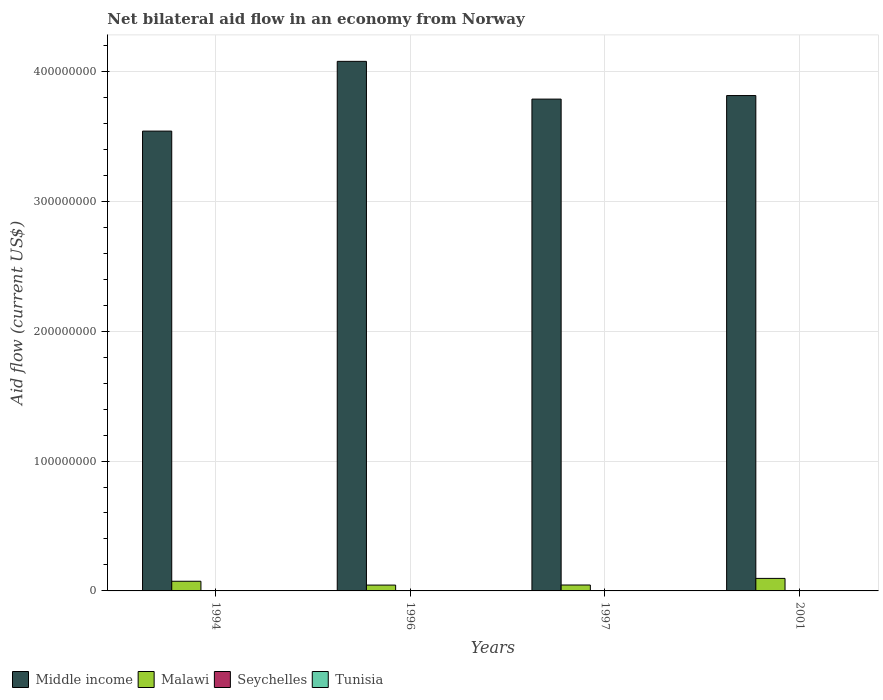How many groups of bars are there?
Provide a short and direct response. 4. How many bars are there on the 1st tick from the right?
Your answer should be compact. 4. What is the label of the 1st group of bars from the left?
Provide a short and direct response. 1994. In how many cases, is the number of bars for a given year not equal to the number of legend labels?
Offer a very short reply. 0. What is the net bilateral aid flow in Seychelles in 1997?
Your response must be concise. 2.00e+04. Across all years, what is the maximum net bilateral aid flow in Malawi?
Offer a very short reply. 9.64e+06. Across all years, what is the minimum net bilateral aid flow in Malawi?
Make the answer very short. 4.49e+06. In which year was the net bilateral aid flow in Malawi maximum?
Ensure brevity in your answer.  2001. What is the total net bilateral aid flow in Malawi in the graph?
Provide a succinct answer. 2.61e+07. What is the difference between the net bilateral aid flow in Seychelles in 1996 and the net bilateral aid flow in Malawi in 1994?
Ensure brevity in your answer.  -7.29e+06. What is the average net bilateral aid flow in Middle income per year?
Offer a very short reply. 3.80e+08. In the year 2001, what is the difference between the net bilateral aid flow in Middle income and net bilateral aid flow in Tunisia?
Make the answer very short. 3.81e+08. In how many years, is the net bilateral aid flow in Tunisia greater than 100000000 US$?
Your answer should be very brief. 0. What is the ratio of the net bilateral aid flow in Tunisia in 1996 to that in 2001?
Offer a terse response. 1. What is the difference between the highest and the second highest net bilateral aid flow in Middle income?
Your response must be concise. 2.63e+07. What is the difference between the highest and the lowest net bilateral aid flow in Middle income?
Keep it short and to the point. 5.37e+07. What does the 3rd bar from the left in 2001 represents?
Ensure brevity in your answer.  Seychelles. What does the 4th bar from the right in 1996 represents?
Offer a very short reply. Middle income. Is it the case that in every year, the sum of the net bilateral aid flow in Middle income and net bilateral aid flow in Tunisia is greater than the net bilateral aid flow in Malawi?
Give a very brief answer. Yes. How many bars are there?
Your answer should be very brief. 16. Are all the bars in the graph horizontal?
Keep it short and to the point. No. Are the values on the major ticks of Y-axis written in scientific E-notation?
Keep it short and to the point. No. Does the graph contain any zero values?
Provide a succinct answer. No. Does the graph contain grids?
Your response must be concise. Yes. How many legend labels are there?
Provide a succinct answer. 4. What is the title of the graph?
Provide a succinct answer. Net bilateral aid flow in an economy from Norway. Does "World" appear as one of the legend labels in the graph?
Provide a short and direct response. No. What is the label or title of the X-axis?
Make the answer very short. Years. What is the label or title of the Y-axis?
Keep it short and to the point. Aid flow (current US$). What is the Aid flow (current US$) of Middle income in 1994?
Offer a terse response. 3.54e+08. What is the Aid flow (current US$) of Malawi in 1994?
Your answer should be very brief. 7.44e+06. What is the Aid flow (current US$) in Tunisia in 1994?
Make the answer very short. 7.00e+04. What is the Aid flow (current US$) of Middle income in 1996?
Offer a terse response. 4.08e+08. What is the Aid flow (current US$) of Malawi in 1996?
Provide a short and direct response. 4.49e+06. What is the Aid flow (current US$) in Seychelles in 1996?
Give a very brief answer. 1.50e+05. What is the Aid flow (current US$) in Tunisia in 1996?
Make the answer very short. 3.00e+04. What is the Aid flow (current US$) in Middle income in 1997?
Give a very brief answer. 3.79e+08. What is the Aid flow (current US$) of Malawi in 1997?
Your response must be concise. 4.55e+06. What is the Aid flow (current US$) of Tunisia in 1997?
Keep it short and to the point. 1.20e+05. What is the Aid flow (current US$) of Middle income in 2001?
Your response must be concise. 3.81e+08. What is the Aid flow (current US$) in Malawi in 2001?
Keep it short and to the point. 9.64e+06. What is the Aid flow (current US$) of Tunisia in 2001?
Give a very brief answer. 3.00e+04. Across all years, what is the maximum Aid flow (current US$) of Middle income?
Your answer should be very brief. 4.08e+08. Across all years, what is the maximum Aid flow (current US$) in Malawi?
Provide a short and direct response. 9.64e+06. Across all years, what is the maximum Aid flow (current US$) of Seychelles?
Provide a short and direct response. 1.50e+05. Across all years, what is the minimum Aid flow (current US$) of Middle income?
Offer a very short reply. 3.54e+08. Across all years, what is the minimum Aid flow (current US$) in Malawi?
Your answer should be very brief. 4.49e+06. Across all years, what is the minimum Aid flow (current US$) of Seychelles?
Your answer should be very brief. 10000. Across all years, what is the minimum Aid flow (current US$) in Tunisia?
Your response must be concise. 3.00e+04. What is the total Aid flow (current US$) of Middle income in the graph?
Your response must be concise. 1.52e+09. What is the total Aid flow (current US$) of Malawi in the graph?
Keep it short and to the point. 2.61e+07. What is the total Aid flow (current US$) of Seychelles in the graph?
Your answer should be compact. 2.80e+05. What is the difference between the Aid flow (current US$) of Middle income in 1994 and that in 1996?
Offer a terse response. -5.37e+07. What is the difference between the Aid flow (current US$) in Malawi in 1994 and that in 1996?
Your answer should be very brief. 2.95e+06. What is the difference between the Aid flow (current US$) of Seychelles in 1994 and that in 1996?
Give a very brief answer. -5.00e+04. What is the difference between the Aid flow (current US$) in Tunisia in 1994 and that in 1996?
Provide a succinct answer. 4.00e+04. What is the difference between the Aid flow (current US$) in Middle income in 1994 and that in 1997?
Your answer should be very brief. -2.46e+07. What is the difference between the Aid flow (current US$) in Malawi in 1994 and that in 1997?
Offer a very short reply. 2.89e+06. What is the difference between the Aid flow (current US$) in Middle income in 1994 and that in 2001?
Offer a terse response. -2.74e+07. What is the difference between the Aid flow (current US$) in Malawi in 1994 and that in 2001?
Provide a short and direct response. -2.20e+06. What is the difference between the Aid flow (current US$) in Seychelles in 1994 and that in 2001?
Provide a short and direct response. 9.00e+04. What is the difference between the Aid flow (current US$) in Middle income in 1996 and that in 1997?
Your answer should be very brief. 2.91e+07. What is the difference between the Aid flow (current US$) in Malawi in 1996 and that in 1997?
Provide a short and direct response. -6.00e+04. What is the difference between the Aid flow (current US$) in Seychelles in 1996 and that in 1997?
Offer a very short reply. 1.30e+05. What is the difference between the Aid flow (current US$) in Middle income in 1996 and that in 2001?
Offer a very short reply. 2.63e+07. What is the difference between the Aid flow (current US$) of Malawi in 1996 and that in 2001?
Your answer should be very brief. -5.15e+06. What is the difference between the Aid flow (current US$) of Middle income in 1997 and that in 2001?
Give a very brief answer. -2.73e+06. What is the difference between the Aid flow (current US$) in Malawi in 1997 and that in 2001?
Your answer should be compact. -5.09e+06. What is the difference between the Aid flow (current US$) of Seychelles in 1997 and that in 2001?
Make the answer very short. 10000. What is the difference between the Aid flow (current US$) of Middle income in 1994 and the Aid flow (current US$) of Malawi in 1996?
Provide a short and direct response. 3.50e+08. What is the difference between the Aid flow (current US$) of Middle income in 1994 and the Aid flow (current US$) of Seychelles in 1996?
Your answer should be very brief. 3.54e+08. What is the difference between the Aid flow (current US$) of Middle income in 1994 and the Aid flow (current US$) of Tunisia in 1996?
Keep it short and to the point. 3.54e+08. What is the difference between the Aid flow (current US$) in Malawi in 1994 and the Aid flow (current US$) in Seychelles in 1996?
Your answer should be compact. 7.29e+06. What is the difference between the Aid flow (current US$) of Malawi in 1994 and the Aid flow (current US$) of Tunisia in 1996?
Offer a terse response. 7.41e+06. What is the difference between the Aid flow (current US$) of Seychelles in 1994 and the Aid flow (current US$) of Tunisia in 1996?
Your response must be concise. 7.00e+04. What is the difference between the Aid flow (current US$) of Middle income in 1994 and the Aid flow (current US$) of Malawi in 1997?
Ensure brevity in your answer.  3.50e+08. What is the difference between the Aid flow (current US$) of Middle income in 1994 and the Aid flow (current US$) of Seychelles in 1997?
Keep it short and to the point. 3.54e+08. What is the difference between the Aid flow (current US$) in Middle income in 1994 and the Aid flow (current US$) in Tunisia in 1997?
Ensure brevity in your answer.  3.54e+08. What is the difference between the Aid flow (current US$) of Malawi in 1994 and the Aid flow (current US$) of Seychelles in 1997?
Provide a short and direct response. 7.42e+06. What is the difference between the Aid flow (current US$) of Malawi in 1994 and the Aid flow (current US$) of Tunisia in 1997?
Ensure brevity in your answer.  7.32e+06. What is the difference between the Aid flow (current US$) in Middle income in 1994 and the Aid flow (current US$) in Malawi in 2001?
Offer a terse response. 3.44e+08. What is the difference between the Aid flow (current US$) in Middle income in 1994 and the Aid flow (current US$) in Seychelles in 2001?
Your answer should be compact. 3.54e+08. What is the difference between the Aid flow (current US$) in Middle income in 1994 and the Aid flow (current US$) in Tunisia in 2001?
Ensure brevity in your answer.  3.54e+08. What is the difference between the Aid flow (current US$) of Malawi in 1994 and the Aid flow (current US$) of Seychelles in 2001?
Your answer should be compact. 7.43e+06. What is the difference between the Aid flow (current US$) in Malawi in 1994 and the Aid flow (current US$) in Tunisia in 2001?
Provide a succinct answer. 7.41e+06. What is the difference between the Aid flow (current US$) in Seychelles in 1994 and the Aid flow (current US$) in Tunisia in 2001?
Your answer should be very brief. 7.00e+04. What is the difference between the Aid flow (current US$) of Middle income in 1996 and the Aid flow (current US$) of Malawi in 1997?
Provide a short and direct response. 4.03e+08. What is the difference between the Aid flow (current US$) of Middle income in 1996 and the Aid flow (current US$) of Seychelles in 1997?
Offer a very short reply. 4.08e+08. What is the difference between the Aid flow (current US$) of Middle income in 1996 and the Aid flow (current US$) of Tunisia in 1997?
Offer a terse response. 4.08e+08. What is the difference between the Aid flow (current US$) in Malawi in 1996 and the Aid flow (current US$) in Seychelles in 1997?
Offer a terse response. 4.47e+06. What is the difference between the Aid flow (current US$) in Malawi in 1996 and the Aid flow (current US$) in Tunisia in 1997?
Keep it short and to the point. 4.37e+06. What is the difference between the Aid flow (current US$) of Middle income in 1996 and the Aid flow (current US$) of Malawi in 2001?
Ensure brevity in your answer.  3.98e+08. What is the difference between the Aid flow (current US$) in Middle income in 1996 and the Aid flow (current US$) in Seychelles in 2001?
Ensure brevity in your answer.  4.08e+08. What is the difference between the Aid flow (current US$) of Middle income in 1996 and the Aid flow (current US$) of Tunisia in 2001?
Your answer should be very brief. 4.08e+08. What is the difference between the Aid flow (current US$) of Malawi in 1996 and the Aid flow (current US$) of Seychelles in 2001?
Your answer should be very brief. 4.48e+06. What is the difference between the Aid flow (current US$) of Malawi in 1996 and the Aid flow (current US$) of Tunisia in 2001?
Offer a terse response. 4.46e+06. What is the difference between the Aid flow (current US$) in Seychelles in 1996 and the Aid flow (current US$) in Tunisia in 2001?
Make the answer very short. 1.20e+05. What is the difference between the Aid flow (current US$) in Middle income in 1997 and the Aid flow (current US$) in Malawi in 2001?
Provide a succinct answer. 3.69e+08. What is the difference between the Aid flow (current US$) in Middle income in 1997 and the Aid flow (current US$) in Seychelles in 2001?
Your answer should be compact. 3.79e+08. What is the difference between the Aid flow (current US$) of Middle income in 1997 and the Aid flow (current US$) of Tunisia in 2001?
Keep it short and to the point. 3.79e+08. What is the difference between the Aid flow (current US$) in Malawi in 1997 and the Aid flow (current US$) in Seychelles in 2001?
Make the answer very short. 4.54e+06. What is the difference between the Aid flow (current US$) of Malawi in 1997 and the Aid flow (current US$) of Tunisia in 2001?
Your answer should be compact. 4.52e+06. What is the average Aid flow (current US$) of Middle income per year?
Provide a succinct answer. 3.80e+08. What is the average Aid flow (current US$) in Malawi per year?
Provide a succinct answer. 6.53e+06. What is the average Aid flow (current US$) of Tunisia per year?
Provide a short and direct response. 6.25e+04. In the year 1994, what is the difference between the Aid flow (current US$) of Middle income and Aid flow (current US$) of Malawi?
Your answer should be compact. 3.47e+08. In the year 1994, what is the difference between the Aid flow (current US$) of Middle income and Aid flow (current US$) of Seychelles?
Provide a succinct answer. 3.54e+08. In the year 1994, what is the difference between the Aid flow (current US$) of Middle income and Aid flow (current US$) of Tunisia?
Your response must be concise. 3.54e+08. In the year 1994, what is the difference between the Aid flow (current US$) of Malawi and Aid flow (current US$) of Seychelles?
Offer a very short reply. 7.34e+06. In the year 1994, what is the difference between the Aid flow (current US$) in Malawi and Aid flow (current US$) in Tunisia?
Offer a terse response. 7.37e+06. In the year 1996, what is the difference between the Aid flow (current US$) in Middle income and Aid flow (current US$) in Malawi?
Offer a very short reply. 4.03e+08. In the year 1996, what is the difference between the Aid flow (current US$) of Middle income and Aid flow (current US$) of Seychelles?
Your response must be concise. 4.08e+08. In the year 1996, what is the difference between the Aid flow (current US$) in Middle income and Aid flow (current US$) in Tunisia?
Provide a succinct answer. 4.08e+08. In the year 1996, what is the difference between the Aid flow (current US$) in Malawi and Aid flow (current US$) in Seychelles?
Offer a terse response. 4.34e+06. In the year 1996, what is the difference between the Aid flow (current US$) of Malawi and Aid flow (current US$) of Tunisia?
Your answer should be compact. 4.46e+06. In the year 1997, what is the difference between the Aid flow (current US$) in Middle income and Aid flow (current US$) in Malawi?
Give a very brief answer. 3.74e+08. In the year 1997, what is the difference between the Aid flow (current US$) of Middle income and Aid flow (current US$) of Seychelles?
Your answer should be very brief. 3.79e+08. In the year 1997, what is the difference between the Aid flow (current US$) of Middle income and Aid flow (current US$) of Tunisia?
Keep it short and to the point. 3.79e+08. In the year 1997, what is the difference between the Aid flow (current US$) in Malawi and Aid flow (current US$) in Seychelles?
Ensure brevity in your answer.  4.53e+06. In the year 1997, what is the difference between the Aid flow (current US$) of Malawi and Aid flow (current US$) of Tunisia?
Your answer should be very brief. 4.43e+06. In the year 2001, what is the difference between the Aid flow (current US$) of Middle income and Aid flow (current US$) of Malawi?
Offer a very short reply. 3.72e+08. In the year 2001, what is the difference between the Aid flow (current US$) in Middle income and Aid flow (current US$) in Seychelles?
Your answer should be very brief. 3.81e+08. In the year 2001, what is the difference between the Aid flow (current US$) in Middle income and Aid flow (current US$) in Tunisia?
Make the answer very short. 3.81e+08. In the year 2001, what is the difference between the Aid flow (current US$) in Malawi and Aid flow (current US$) in Seychelles?
Make the answer very short. 9.63e+06. In the year 2001, what is the difference between the Aid flow (current US$) of Malawi and Aid flow (current US$) of Tunisia?
Provide a succinct answer. 9.61e+06. What is the ratio of the Aid flow (current US$) in Middle income in 1994 to that in 1996?
Your response must be concise. 0.87. What is the ratio of the Aid flow (current US$) in Malawi in 1994 to that in 1996?
Your answer should be compact. 1.66. What is the ratio of the Aid flow (current US$) of Tunisia in 1994 to that in 1996?
Give a very brief answer. 2.33. What is the ratio of the Aid flow (current US$) in Middle income in 1994 to that in 1997?
Keep it short and to the point. 0.94. What is the ratio of the Aid flow (current US$) of Malawi in 1994 to that in 1997?
Your answer should be very brief. 1.64. What is the ratio of the Aid flow (current US$) in Seychelles in 1994 to that in 1997?
Offer a terse response. 5. What is the ratio of the Aid flow (current US$) of Tunisia in 1994 to that in 1997?
Ensure brevity in your answer.  0.58. What is the ratio of the Aid flow (current US$) of Middle income in 1994 to that in 2001?
Offer a terse response. 0.93. What is the ratio of the Aid flow (current US$) of Malawi in 1994 to that in 2001?
Offer a terse response. 0.77. What is the ratio of the Aid flow (current US$) in Tunisia in 1994 to that in 2001?
Give a very brief answer. 2.33. What is the ratio of the Aid flow (current US$) of Middle income in 1996 to that in 1997?
Your answer should be compact. 1.08. What is the ratio of the Aid flow (current US$) of Malawi in 1996 to that in 1997?
Keep it short and to the point. 0.99. What is the ratio of the Aid flow (current US$) of Seychelles in 1996 to that in 1997?
Your answer should be compact. 7.5. What is the ratio of the Aid flow (current US$) of Middle income in 1996 to that in 2001?
Your answer should be very brief. 1.07. What is the ratio of the Aid flow (current US$) of Malawi in 1996 to that in 2001?
Ensure brevity in your answer.  0.47. What is the ratio of the Aid flow (current US$) in Seychelles in 1996 to that in 2001?
Keep it short and to the point. 15. What is the ratio of the Aid flow (current US$) in Tunisia in 1996 to that in 2001?
Ensure brevity in your answer.  1. What is the ratio of the Aid flow (current US$) of Middle income in 1997 to that in 2001?
Give a very brief answer. 0.99. What is the ratio of the Aid flow (current US$) in Malawi in 1997 to that in 2001?
Your answer should be compact. 0.47. What is the difference between the highest and the second highest Aid flow (current US$) of Middle income?
Keep it short and to the point. 2.63e+07. What is the difference between the highest and the second highest Aid flow (current US$) of Malawi?
Keep it short and to the point. 2.20e+06. What is the difference between the highest and the second highest Aid flow (current US$) in Seychelles?
Make the answer very short. 5.00e+04. What is the difference between the highest and the lowest Aid flow (current US$) in Middle income?
Provide a short and direct response. 5.37e+07. What is the difference between the highest and the lowest Aid flow (current US$) of Malawi?
Make the answer very short. 5.15e+06. 